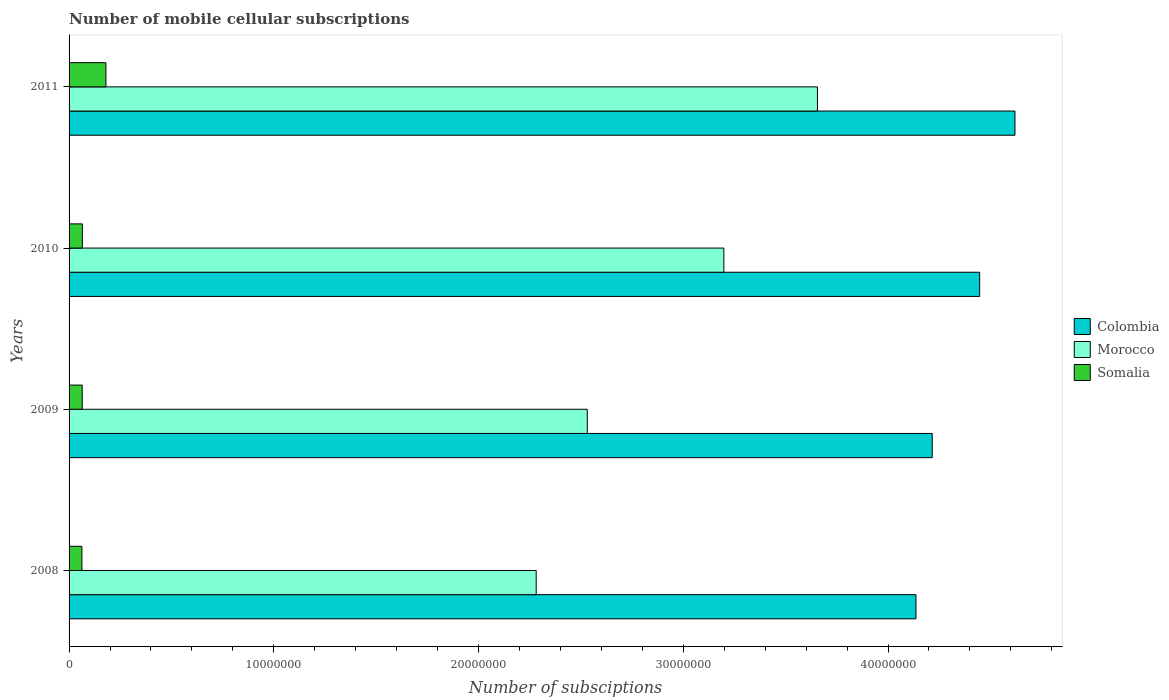How many different coloured bars are there?
Keep it short and to the point. 3. Are the number of bars on each tick of the Y-axis equal?
Provide a short and direct response. Yes. In how many cases, is the number of bars for a given year not equal to the number of legend labels?
Offer a very short reply. 0. What is the number of mobile cellular subscriptions in Morocco in 2008?
Provide a short and direct response. 2.28e+07. Across all years, what is the maximum number of mobile cellular subscriptions in Morocco?
Offer a very short reply. 3.66e+07. Across all years, what is the minimum number of mobile cellular subscriptions in Colombia?
Your answer should be very brief. 4.14e+07. What is the total number of mobile cellular subscriptions in Colombia in the graph?
Your response must be concise. 1.74e+08. What is the difference between the number of mobile cellular subscriptions in Colombia in 2009 and that in 2011?
Keep it short and to the point. -4.04e+06. What is the difference between the number of mobile cellular subscriptions in Colombia in 2011 and the number of mobile cellular subscriptions in Morocco in 2008?
Offer a very short reply. 2.34e+07. What is the average number of mobile cellular subscriptions in Morocco per year?
Make the answer very short. 2.92e+07. In the year 2011, what is the difference between the number of mobile cellular subscriptions in Morocco and number of mobile cellular subscriptions in Somalia?
Your answer should be compact. 3.48e+07. What is the ratio of the number of mobile cellular subscriptions in Somalia in 2008 to that in 2010?
Offer a very short reply. 0.97. What is the difference between the highest and the second highest number of mobile cellular subscriptions in Colombia?
Ensure brevity in your answer.  1.72e+06. What is the difference between the highest and the lowest number of mobile cellular subscriptions in Colombia?
Your answer should be very brief. 4.84e+06. In how many years, is the number of mobile cellular subscriptions in Morocco greater than the average number of mobile cellular subscriptions in Morocco taken over all years?
Keep it short and to the point. 2. Is the sum of the number of mobile cellular subscriptions in Colombia in 2009 and 2011 greater than the maximum number of mobile cellular subscriptions in Morocco across all years?
Offer a terse response. Yes. What does the 2nd bar from the top in 2008 represents?
Your response must be concise. Morocco. What does the 3rd bar from the bottom in 2009 represents?
Your response must be concise. Somalia. How many bars are there?
Offer a very short reply. 12. What is the difference between two consecutive major ticks on the X-axis?
Make the answer very short. 1.00e+07. Are the values on the major ticks of X-axis written in scientific E-notation?
Ensure brevity in your answer.  No. Does the graph contain grids?
Provide a succinct answer. No. Where does the legend appear in the graph?
Offer a very short reply. Center right. How many legend labels are there?
Make the answer very short. 3. What is the title of the graph?
Provide a short and direct response. Number of mobile cellular subscriptions. Does "Belarus" appear as one of the legend labels in the graph?
Keep it short and to the point. No. What is the label or title of the X-axis?
Provide a succinct answer. Number of subsciptions. What is the label or title of the Y-axis?
Your answer should be very brief. Years. What is the Number of subsciptions in Colombia in 2008?
Offer a very short reply. 4.14e+07. What is the Number of subsciptions of Morocco in 2008?
Keep it short and to the point. 2.28e+07. What is the Number of subsciptions in Somalia in 2008?
Your answer should be very brief. 6.27e+05. What is the Number of subsciptions in Colombia in 2009?
Offer a very short reply. 4.22e+07. What is the Number of subsciptions in Morocco in 2009?
Your answer should be compact. 2.53e+07. What is the Number of subsciptions of Somalia in 2009?
Give a very brief answer. 6.41e+05. What is the Number of subsciptions of Colombia in 2010?
Offer a terse response. 4.45e+07. What is the Number of subsciptions in Morocco in 2010?
Make the answer very short. 3.20e+07. What is the Number of subsciptions of Somalia in 2010?
Make the answer very short. 6.48e+05. What is the Number of subsciptions of Colombia in 2011?
Offer a very short reply. 4.62e+07. What is the Number of subsciptions of Morocco in 2011?
Make the answer very short. 3.66e+07. What is the Number of subsciptions of Somalia in 2011?
Ensure brevity in your answer.  1.80e+06. Across all years, what is the maximum Number of subsciptions in Colombia?
Give a very brief answer. 4.62e+07. Across all years, what is the maximum Number of subsciptions of Morocco?
Your answer should be compact. 3.66e+07. Across all years, what is the maximum Number of subsciptions of Somalia?
Offer a terse response. 1.80e+06. Across all years, what is the minimum Number of subsciptions of Colombia?
Offer a terse response. 4.14e+07. Across all years, what is the minimum Number of subsciptions in Morocco?
Make the answer very short. 2.28e+07. Across all years, what is the minimum Number of subsciptions of Somalia?
Your response must be concise. 6.27e+05. What is the total Number of subsciptions in Colombia in the graph?
Your answer should be compact. 1.74e+08. What is the total Number of subsciptions of Morocco in the graph?
Your answer should be very brief. 1.17e+08. What is the total Number of subsciptions of Somalia in the graph?
Provide a succinct answer. 3.72e+06. What is the difference between the Number of subsciptions in Colombia in 2008 and that in 2009?
Offer a very short reply. -7.95e+05. What is the difference between the Number of subsciptions of Morocco in 2008 and that in 2009?
Give a very brief answer. -2.50e+06. What is the difference between the Number of subsciptions of Somalia in 2008 and that in 2009?
Offer a terse response. -1.40e+04. What is the difference between the Number of subsciptions of Colombia in 2008 and that in 2010?
Offer a terse response. -3.11e+06. What is the difference between the Number of subsciptions in Morocco in 2008 and that in 2010?
Ensure brevity in your answer.  -9.17e+06. What is the difference between the Number of subsciptions of Somalia in 2008 and that in 2010?
Offer a very short reply. -2.12e+04. What is the difference between the Number of subsciptions of Colombia in 2008 and that in 2011?
Provide a short and direct response. -4.84e+06. What is the difference between the Number of subsciptions of Morocco in 2008 and that in 2011?
Your answer should be very brief. -1.37e+07. What is the difference between the Number of subsciptions in Somalia in 2008 and that in 2011?
Make the answer very short. -1.17e+06. What is the difference between the Number of subsciptions in Colombia in 2009 and that in 2010?
Offer a terse response. -2.32e+06. What is the difference between the Number of subsciptions in Morocco in 2009 and that in 2010?
Offer a terse response. -6.67e+06. What is the difference between the Number of subsciptions of Somalia in 2009 and that in 2010?
Offer a terse response. -7200. What is the difference between the Number of subsciptions in Colombia in 2009 and that in 2011?
Offer a terse response. -4.04e+06. What is the difference between the Number of subsciptions of Morocco in 2009 and that in 2011?
Offer a terse response. -1.12e+07. What is the difference between the Number of subsciptions in Somalia in 2009 and that in 2011?
Your answer should be compact. -1.16e+06. What is the difference between the Number of subsciptions of Colombia in 2010 and that in 2011?
Your answer should be very brief. -1.72e+06. What is the difference between the Number of subsciptions in Morocco in 2010 and that in 2011?
Your answer should be very brief. -4.57e+06. What is the difference between the Number of subsciptions in Somalia in 2010 and that in 2011?
Provide a succinct answer. -1.15e+06. What is the difference between the Number of subsciptions in Colombia in 2008 and the Number of subsciptions in Morocco in 2009?
Ensure brevity in your answer.  1.61e+07. What is the difference between the Number of subsciptions in Colombia in 2008 and the Number of subsciptions in Somalia in 2009?
Keep it short and to the point. 4.07e+07. What is the difference between the Number of subsciptions in Morocco in 2008 and the Number of subsciptions in Somalia in 2009?
Your response must be concise. 2.22e+07. What is the difference between the Number of subsciptions in Colombia in 2008 and the Number of subsciptions in Morocco in 2010?
Ensure brevity in your answer.  9.38e+06. What is the difference between the Number of subsciptions of Colombia in 2008 and the Number of subsciptions of Somalia in 2010?
Your response must be concise. 4.07e+07. What is the difference between the Number of subsciptions in Morocco in 2008 and the Number of subsciptions in Somalia in 2010?
Your response must be concise. 2.22e+07. What is the difference between the Number of subsciptions of Colombia in 2008 and the Number of subsciptions of Morocco in 2011?
Your answer should be compact. 4.81e+06. What is the difference between the Number of subsciptions in Colombia in 2008 and the Number of subsciptions in Somalia in 2011?
Offer a terse response. 3.96e+07. What is the difference between the Number of subsciptions in Morocco in 2008 and the Number of subsciptions in Somalia in 2011?
Your answer should be very brief. 2.10e+07. What is the difference between the Number of subsciptions of Colombia in 2009 and the Number of subsciptions of Morocco in 2010?
Your answer should be very brief. 1.02e+07. What is the difference between the Number of subsciptions of Colombia in 2009 and the Number of subsciptions of Somalia in 2010?
Offer a very short reply. 4.15e+07. What is the difference between the Number of subsciptions of Morocco in 2009 and the Number of subsciptions of Somalia in 2010?
Your response must be concise. 2.47e+07. What is the difference between the Number of subsciptions in Colombia in 2009 and the Number of subsciptions in Morocco in 2011?
Offer a terse response. 5.61e+06. What is the difference between the Number of subsciptions in Colombia in 2009 and the Number of subsciptions in Somalia in 2011?
Provide a succinct answer. 4.04e+07. What is the difference between the Number of subsciptions in Morocco in 2009 and the Number of subsciptions in Somalia in 2011?
Keep it short and to the point. 2.35e+07. What is the difference between the Number of subsciptions in Colombia in 2010 and the Number of subsciptions in Morocco in 2011?
Keep it short and to the point. 7.92e+06. What is the difference between the Number of subsciptions of Colombia in 2010 and the Number of subsciptions of Somalia in 2011?
Provide a short and direct response. 4.27e+07. What is the difference between the Number of subsciptions in Morocco in 2010 and the Number of subsciptions in Somalia in 2011?
Offer a very short reply. 3.02e+07. What is the average Number of subsciptions of Colombia per year?
Give a very brief answer. 4.36e+07. What is the average Number of subsciptions in Morocco per year?
Offer a very short reply. 2.92e+07. What is the average Number of subsciptions in Somalia per year?
Ensure brevity in your answer.  9.29e+05. In the year 2008, what is the difference between the Number of subsciptions of Colombia and Number of subsciptions of Morocco?
Provide a succinct answer. 1.85e+07. In the year 2008, what is the difference between the Number of subsciptions in Colombia and Number of subsciptions in Somalia?
Your answer should be very brief. 4.07e+07. In the year 2008, what is the difference between the Number of subsciptions in Morocco and Number of subsciptions in Somalia?
Your answer should be very brief. 2.22e+07. In the year 2009, what is the difference between the Number of subsciptions in Colombia and Number of subsciptions in Morocco?
Provide a succinct answer. 1.68e+07. In the year 2009, what is the difference between the Number of subsciptions in Colombia and Number of subsciptions in Somalia?
Offer a very short reply. 4.15e+07. In the year 2009, what is the difference between the Number of subsciptions in Morocco and Number of subsciptions in Somalia?
Offer a terse response. 2.47e+07. In the year 2010, what is the difference between the Number of subsciptions in Colombia and Number of subsciptions in Morocco?
Offer a terse response. 1.25e+07. In the year 2010, what is the difference between the Number of subsciptions in Colombia and Number of subsciptions in Somalia?
Your answer should be very brief. 4.38e+07. In the year 2010, what is the difference between the Number of subsciptions of Morocco and Number of subsciptions of Somalia?
Make the answer very short. 3.13e+07. In the year 2011, what is the difference between the Number of subsciptions of Colombia and Number of subsciptions of Morocco?
Ensure brevity in your answer.  9.65e+06. In the year 2011, what is the difference between the Number of subsciptions of Colombia and Number of subsciptions of Somalia?
Offer a terse response. 4.44e+07. In the year 2011, what is the difference between the Number of subsciptions in Morocco and Number of subsciptions in Somalia?
Offer a terse response. 3.48e+07. What is the ratio of the Number of subsciptions of Colombia in 2008 to that in 2009?
Make the answer very short. 0.98. What is the ratio of the Number of subsciptions of Morocco in 2008 to that in 2009?
Make the answer very short. 0.9. What is the ratio of the Number of subsciptions in Somalia in 2008 to that in 2009?
Give a very brief answer. 0.98. What is the ratio of the Number of subsciptions of Morocco in 2008 to that in 2010?
Offer a very short reply. 0.71. What is the ratio of the Number of subsciptions of Somalia in 2008 to that in 2010?
Your answer should be very brief. 0.97. What is the ratio of the Number of subsciptions in Colombia in 2008 to that in 2011?
Your response must be concise. 0.9. What is the ratio of the Number of subsciptions of Morocco in 2008 to that in 2011?
Your answer should be very brief. 0.62. What is the ratio of the Number of subsciptions in Somalia in 2008 to that in 2011?
Provide a succinct answer. 0.35. What is the ratio of the Number of subsciptions in Colombia in 2009 to that in 2010?
Offer a very short reply. 0.95. What is the ratio of the Number of subsciptions in Morocco in 2009 to that in 2010?
Offer a terse response. 0.79. What is the ratio of the Number of subsciptions of Somalia in 2009 to that in 2010?
Offer a very short reply. 0.99. What is the ratio of the Number of subsciptions of Colombia in 2009 to that in 2011?
Provide a succinct answer. 0.91. What is the ratio of the Number of subsciptions of Morocco in 2009 to that in 2011?
Offer a terse response. 0.69. What is the ratio of the Number of subsciptions of Somalia in 2009 to that in 2011?
Ensure brevity in your answer.  0.36. What is the ratio of the Number of subsciptions of Colombia in 2010 to that in 2011?
Provide a short and direct response. 0.96. What is the ratio of the Number of subsciptions in Morocco in 2010 to that in 2011?
Your answer should be compact. 0.87. What is the ratio of the Number of subsciptions of Somalia in 2010 to that in 2011?
Offer a very short reply. 0.36. What is the difference between the highest and the second highest Number of subsciptions of Colombia?
Offer a very short reply. 1.72e+06. What is the difference between the highest and the second highest Number of subsciptions of Morocco?
Your answer should be compact. 4.57e+06. What is the difference between the highest and the second highest Number of subsciptions in Somalia?
Ensure brevity in your answer.  1.15e+06. What is the difference between the highest and the lowest Number of subsciptions of Colombia?
Provide a short and direct response. 4.84e+06. What is the difference between the highest and the lowest Number of subsciptions in Morocco?
Ensure brevity in your answer.  1.37e+07. What is the difference between the highest and the lowest Number of subsciptions of Somalia?
Provide a short and direct response. 1.17e+06. 